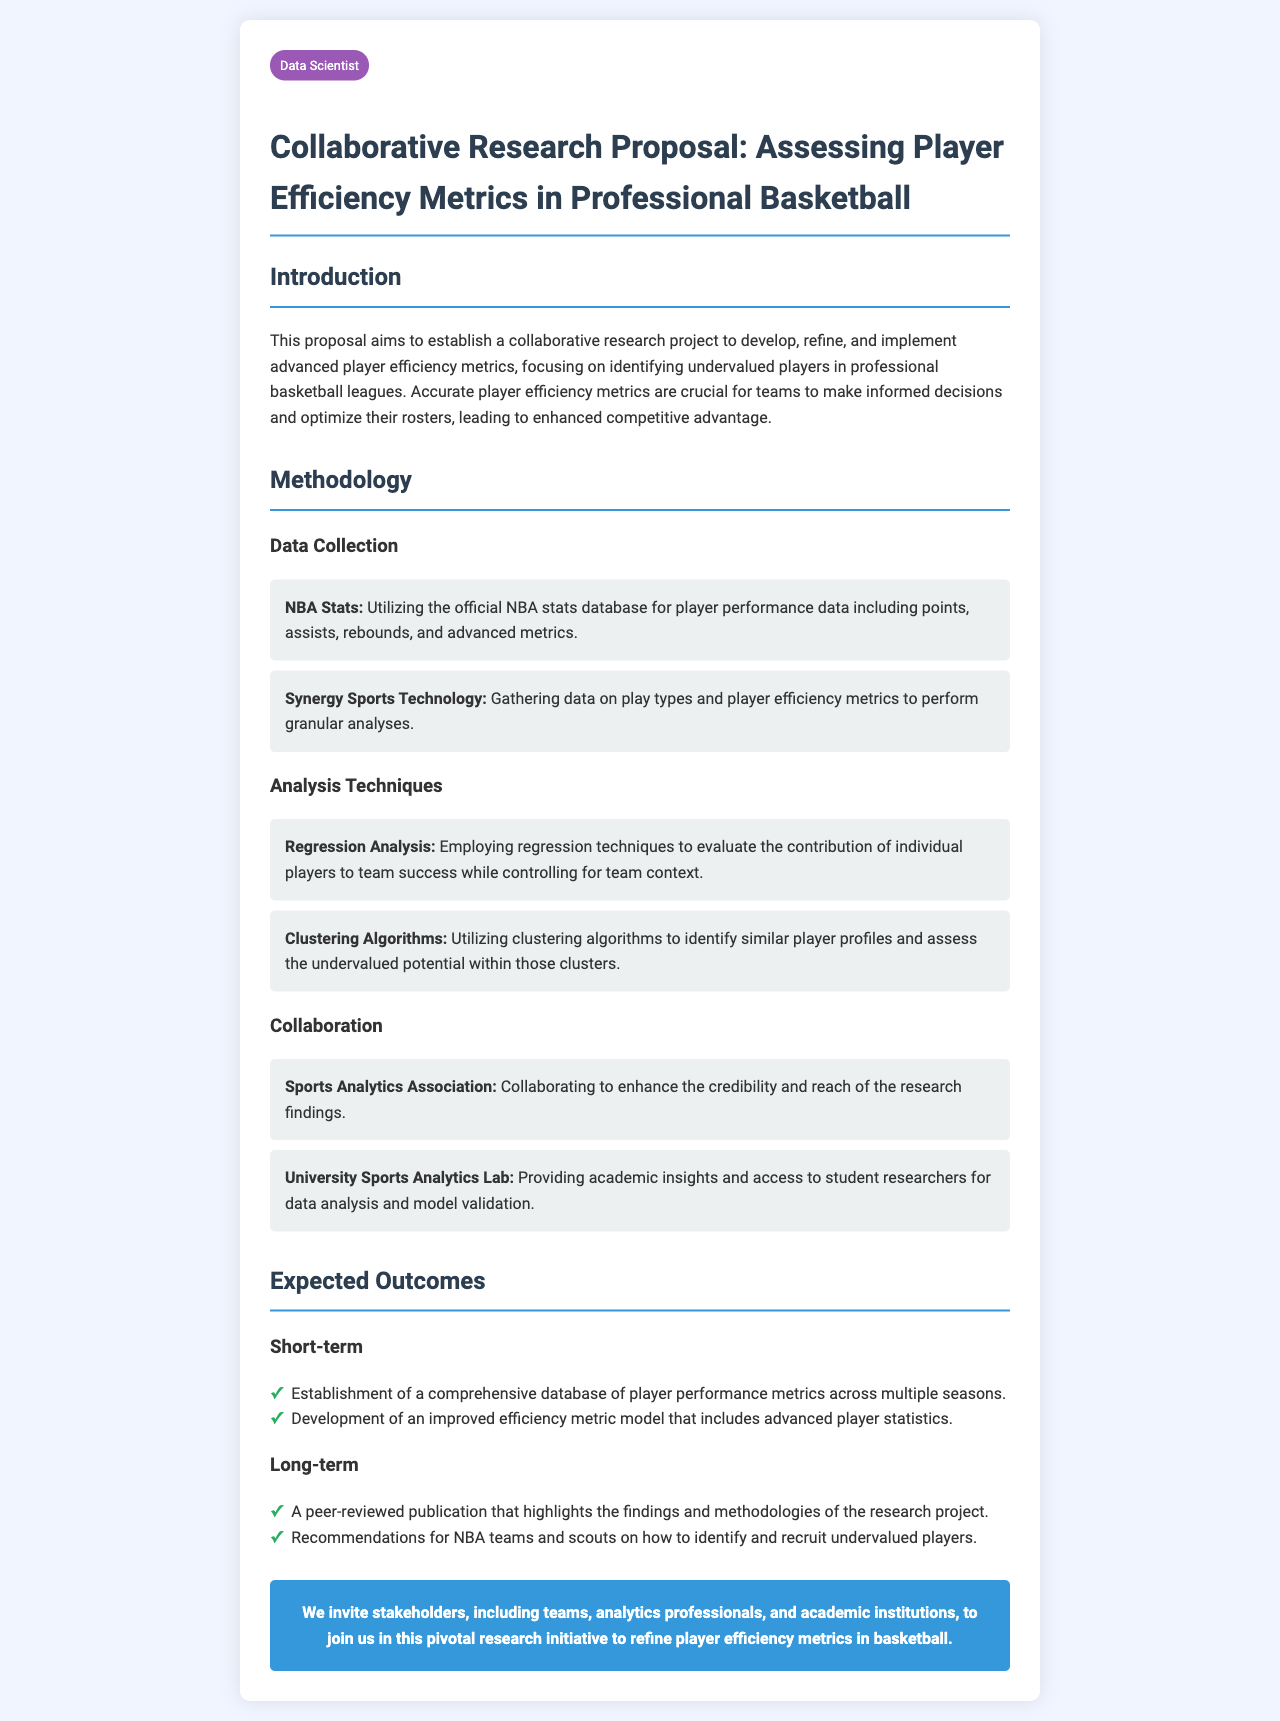What is the main focus of the research proposal? The main focus of the research proposal is to develop, refine, and implement advanced player efficiency metrics.
Answer: Advanced player efficiency metrics Who is the proposal intended for collaboration with? The proposal mentions specific collaborations with organizations that can provide insights and data analysis capabilities.
Answer: Sports Analytics Association, University Sports Analytics Lab What type of data will be collected from the NBA? The proposal specifies the type of data to be collected from the NBA for performance analysis.
Answer: Player performance data including points, assists, rebounds, and advanced metrics What analysis technique will be used to evaluate player contributions? The proposal mentions a specific technique for analyzing the contribution of players within their teams.
Answer: Regression Analysis What is one of the expected short-term outcomes of the research? The expected short-term outcomes list specific achievements that will result from the research project.
Answer: Establishment of a comprehensive database of player performance metrics What type of publication is expected in the long-term outcomes? The long-term outcomes indicate how the findings from the research project will be disseminated.
Answer: A peer-reviewed publication What is included in the methodology regarding play types? The methodology section reveals the data sources used for in-depth analysis related to specific aspects of player performance.
Answer: Synergy Sports Technology What year is referred to in the context of NBA teams and scouting? The proposal hints at the implications of the research regarding a timeframe relevant to team decisions.
Answer: NBA teams and scouts 